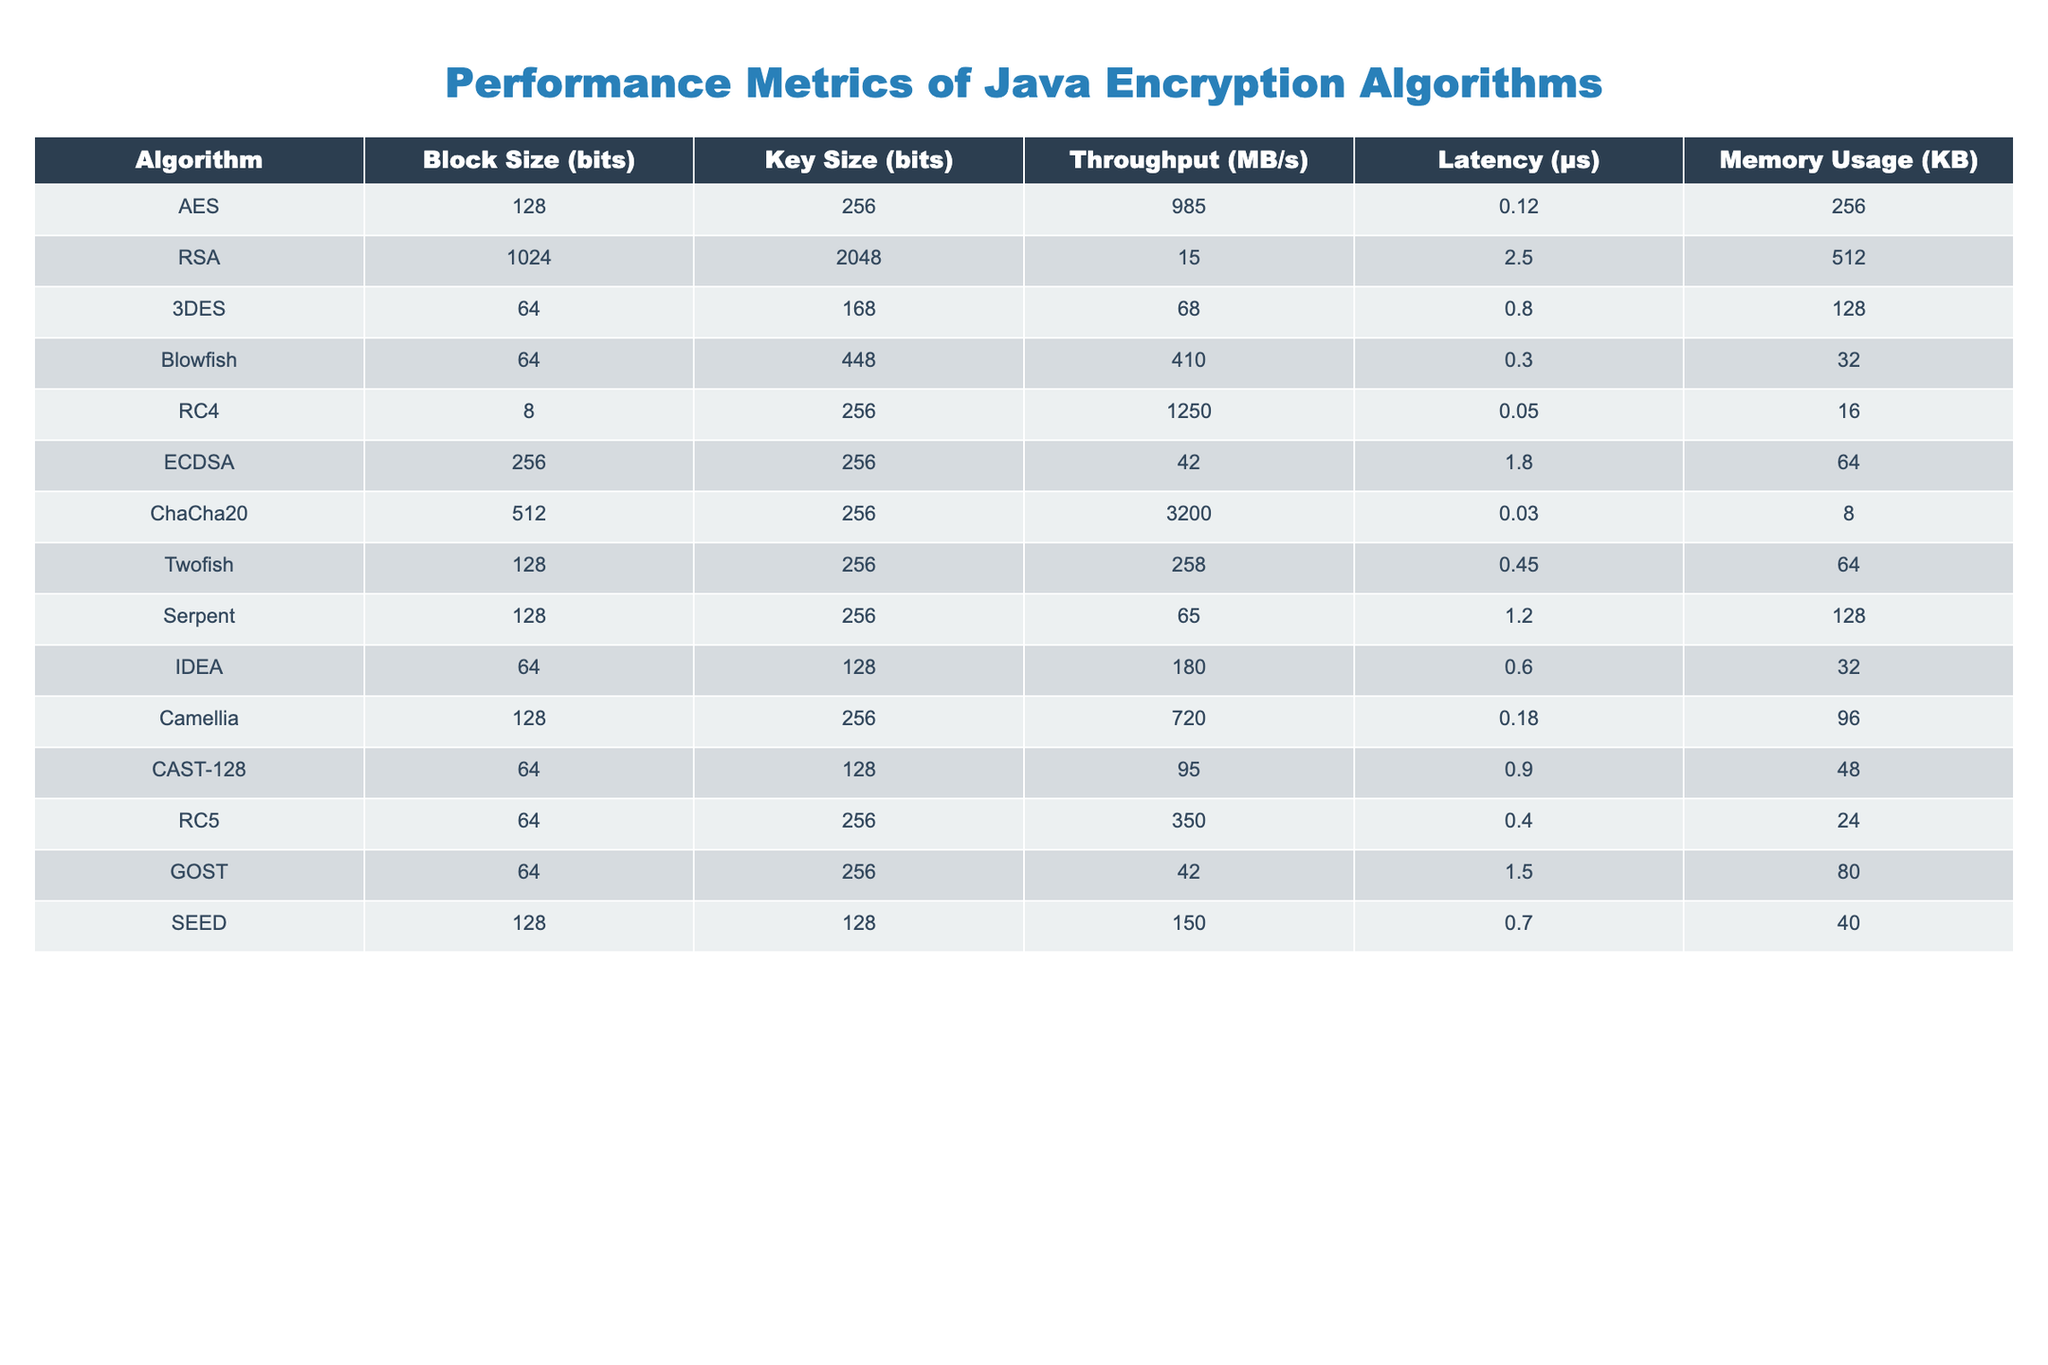What is the throughput of the AES algorithm? The table indicates that the throughput for the AES algorithm is listed directly under the "Throughput (MB/s)" column next to AES. The value is 985.
Answer: 985 Which algorithm has the lowest latency? To find the algorithm with the lowest latency, I look at the "Latency (μs)" column. The lowest value is 0.03, which corresponds to the ChaCha20 algorithm.
Answer: ChaCha20 What is the average memory usage of the algorithms? To calculate the average memory usage, I sum all the memory usage values: 256 + 512 + 128 + 32 + 16 + 64 + 8 + 64 + 128 + 32 + 96 + 48 + 24 + 80 + 40 = 1288 KB. There are 15 algorithms, so the average is 1288 / 15 = 85.87 KB.
Answer: 85.87 Does the RC4 algorithm have more latency than the IDEA algorithm? By comparing the "Latency (μs)" values, RC4 has a latency of 0.05 and IDEA has a latency of 0.6. Since 0.05 is less than 0.6, RC4 has less latency than IDEA.
Answer: No Which algorithm provides the highest throughput? I scan the "Throughput (MB/s)" column to find the maximum value. The maximum throughput is 3200, which belongs to the ChaCha20 algorithm.
Answer: ChaCha20 How much faster is RC4 compared to 3DES in terms of throughput? RC4 has a throughput of 1250 MB/s and 3DES has a throughput of 68 MB/s. The difference is 1250 - 68 = 1182 MB/s, indicating that RC4 is 1182 MB/s faster than 3DES.
Answer: 1182 Is there any algorithm with both high throughput and low latency? I observe that ChaCha20 has the highest throughput (3200 MB/s) and also a low latency of 0.03 μs, which qualifies it as an algorithm with both high throughput and low latency.
Answer: Yes What is the difference in block size between the AES and Twofish algorithms? The block size for AES is 128 bits and for Twofish is also 128 bits, so the difference is 128 - 128 = 0 bits.
Answer: 0 bits What is the median memory usage of the algorithms? To find the median, I must first arrange the memory usages in ascending order: 8, 16, 24, 32, 32, 40, 48, 64, 64, 80, 96, 128, 128, 256, 512. The median is the middle value; with 15 values, the median is the 8th value, which is 64 KB.
Answer: 64 Which algorithm has the highest key size among those listed? When checking the "Key Size (bits)" column, the maximum value is 448 bits, which corresponds to the Blowfish algorithm.
Answer: Blowfish 